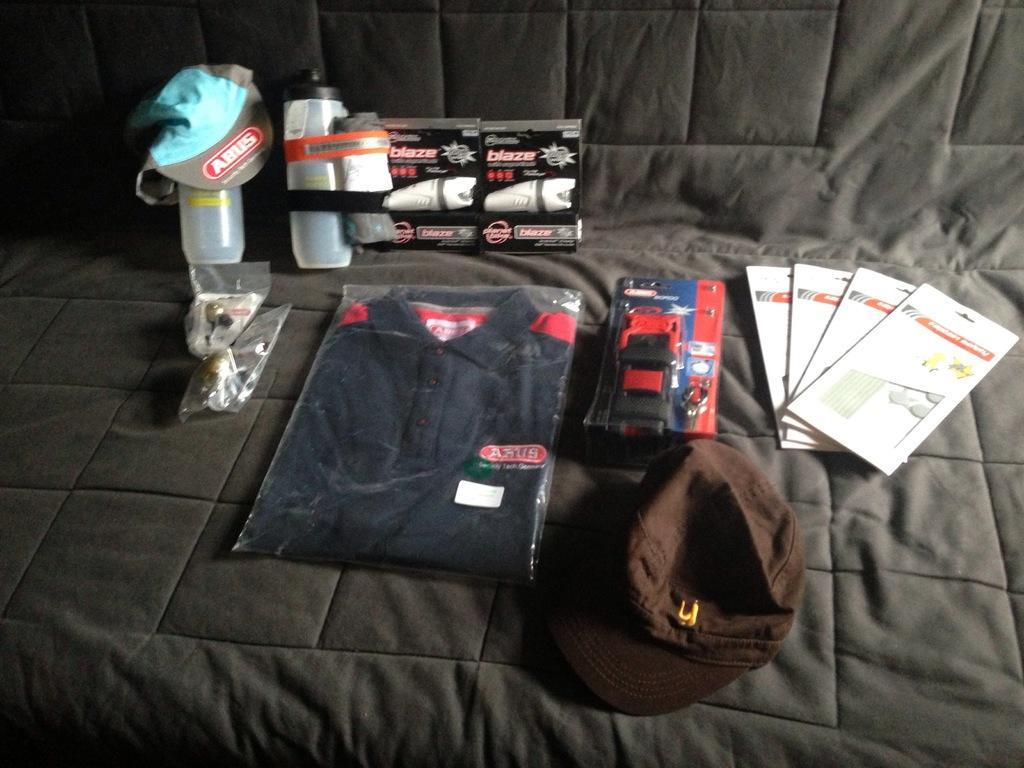Could you give a brief overview of what you see in this image? In this image we can see a T-shirt, few bottle, few caps and few other objects placed on an object. 